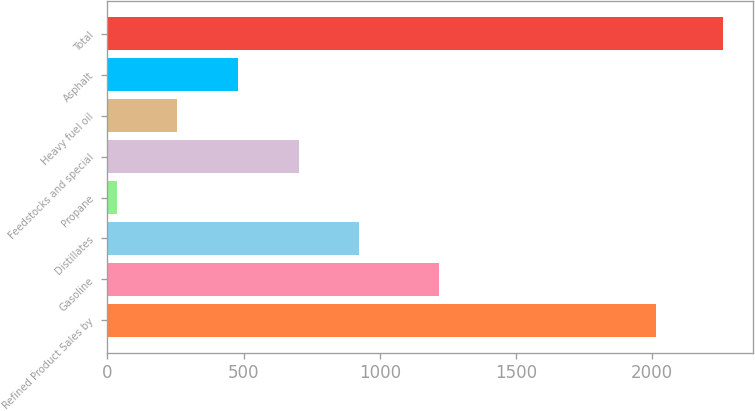Convert chart to OTSL. <chart><loc_0><loc_0><loc_500><loc_500><bar_chart><fcel>Refined Product Sales by<fcel>Gasoline<fcel>Distillates<fcel>Propane<fcel>Feedstocks and special<fcel>Heavy fuel oil<fcel>Asphalt<fcel>Total<nl><fcel>2016<fcel>1219<fcel>924.6<fcel>35<fcel>702.2<fcel>257.4<fcel>479.8<fcel>2259<nl></chart> 